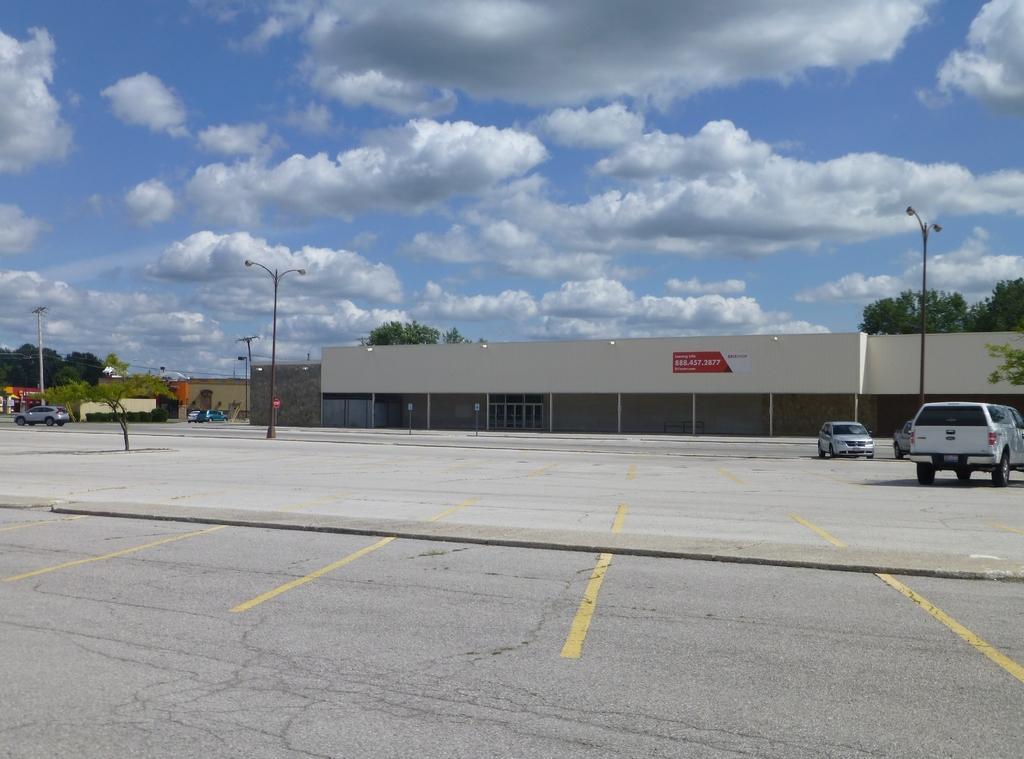Please provide a concise description of this image. In this image we can see there are buildings, trees, light poles and the cloudy sky. And there are vehicles on the ground. 